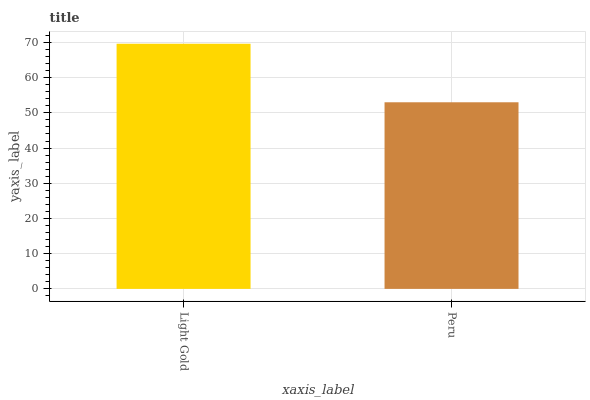Is Peru the minimum?
Answer yes or no. Yes. Is Light Gold the maximum?
Answer yes or no. Yes. Is Peru the maximum?
Answer yes or no. No. Is Light Gold greater than Peru?
Answer yes or no. Yes. Is Peru less than Light Gold?
Answer yes or no. Yes. Is Peru greater than Light Gold?
Answer yes or no. No. Is Light Gold less than Peru?
Answer yes or no. No. Is Light Gold the high median?
Answer yes or no. Yes. Is Peru the low median?
Answer yes or no. Yes. Is Peru the high median?
Answer yes or no. No. Is Light Gold the low median?
Answer yes or no. No. 